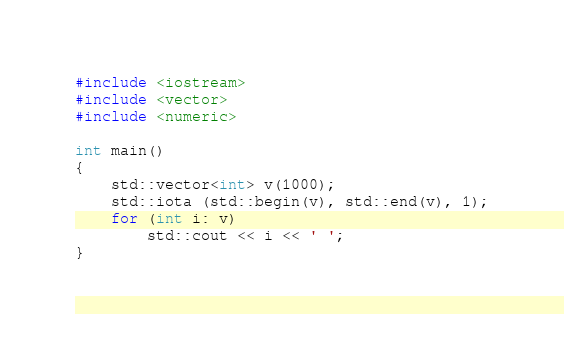Convert code to text. <code><loc_0><loc_0><loc_500><loc_500><_C++_>#include <iostream>
#include <vector>
#include <numeric>

int main()
{
    std::vector<int> v(1000);
    std::iota (std::begin(v), std::end(v), 1);
    for (int i: v)
        std::cout << i << ' ';
}
</code> 